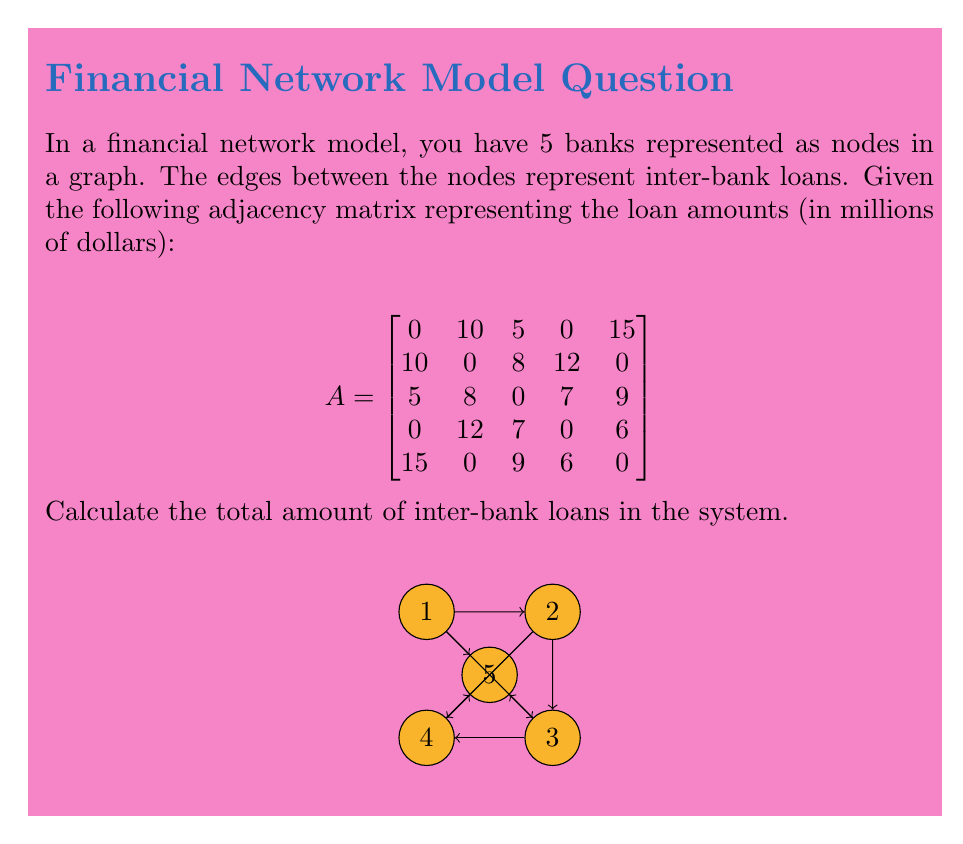Can you solve this math problem? To calculate the total amount of inter-bank loans in the system, we need to sum up all the non-zero entries in the adjacency matrix. However, we need to be careful not to double-count the loans, as each loan is represented twice in the matrix (once for each direction of the edge).

Let's go through this step-by-step:

1) First, we sum up all the non-zero entries in the matrix:
   $10 + 5 + 15 + 10 + 8 + 12 + 5 + 8 + 7 + 9 + 12 + 7 + 6 + 15 + 9 + 6 = 144$

2) However, this sum counts each loan twice. For example, the $10 million loan between banks 1 and 2 is represented by both $A_{12}$ and $A_{21}$.

3) To correct for this double-counting, we need to divide our sum by 2:
   $144 \div 2 = 72$

Therefore, the total amount of inter-bank loans in the system is $72 million.

This method works because the adjacency matrix is symmetric (i.e., $A_{ij} = A_{ji}$), which is a property of undirected graphs. In financial networks, loans are typically modeled as undirected edges because a loan from bank A to bank B is equivalent to a debt from bank B to bank A.
Answer: $72 million 